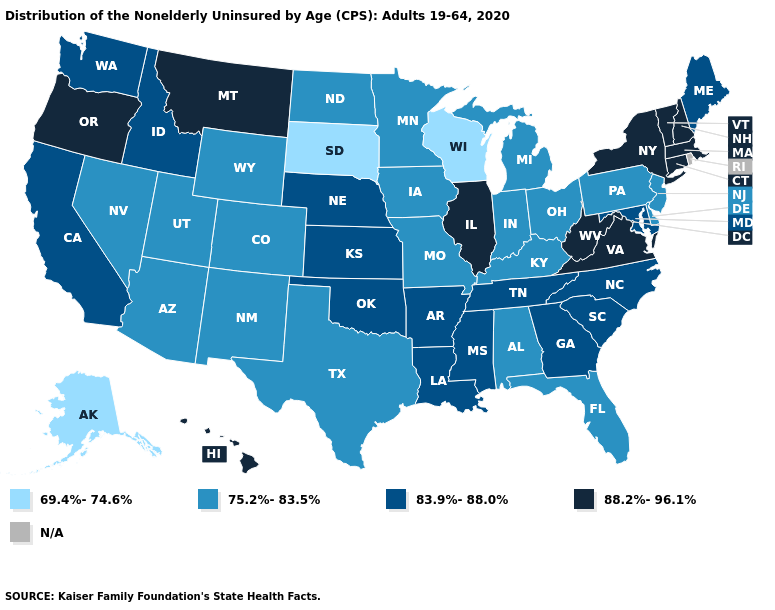Which states have the lowest value in the Northeast?
Keep it brief. New Jersey, Pennsylvania. What is the value of Iowa?
Quick response, please. 75.2%-83.5%. What is the value of Kansas?
Be succinct. 83.9%-88.0%. Among the states that border Georgia , which have the lowest value?
Concise answer only. Alabama, Florida. Does California have the lowest value in the West?
Give a very brief answer. No. Among the states that border Rhode Island , which have the lowest value?
Quick response, please. Connecticut, Massachusetts. What is the value of Maine?
Answer briefly. 83.9%-88.0%. Name the states that have a value in the range 69.4%-74.6%?
Give a very brief answer. Alaska, South Dakota, Wisconsin. Which states have the lowest value in the Northeast?
Quick response, please. New Jersey, Pennsylvania. What is the highest value in the USA?
Quick response, please. 88.2%-96.1%. Name the states that have a value in the range N/A?
Write a very short answer. Rhode Island. Which states have the lowest value in the USA?
Give a very brief answer. Alaska, South Dakota, Wisconsin. What is the lowest value in the USA?
Keep it brief. 69.4%-74.6%. What is the value of Illinois?
Give a very brief answer. 88.2%-96.1%. 